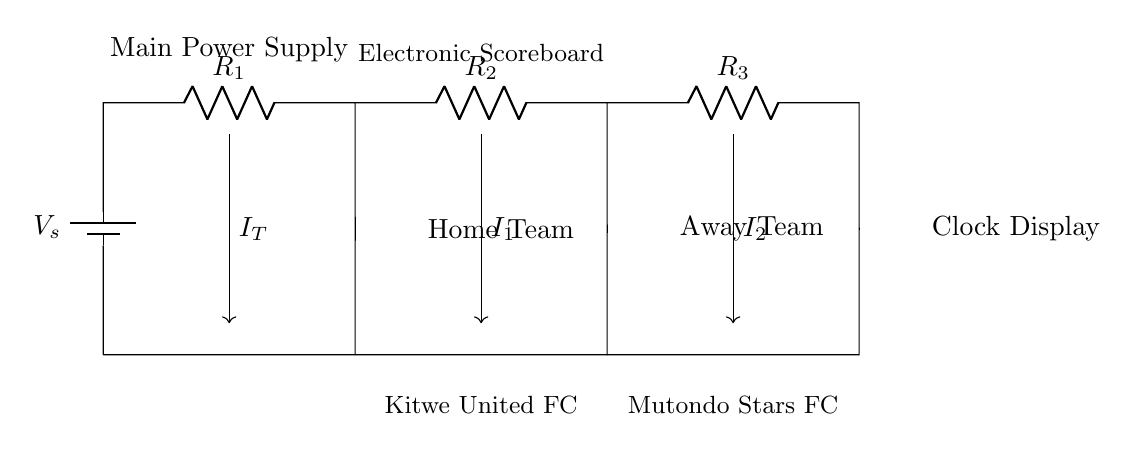What is the total current supplied by the battery? The total current supplied by the battery is denoted as I_T, which is the sum of all currents flowing to the individual branches that power the scoreboard.
Answer: I_T How many resistors are in the circuit? The circuit features three resistors, labeled as R1, R2, and R3, connected in parallel to the main voltage source.
Answer: Three What is the function of the power supply in this circuit? The power supply, represented by the battery, provides the necessary voltage to power the electronic scoreboard and distribute current to the connected components.
Answer: Voltage supply Which team has a separate current flowing to its display? The away team, represented by the current labeled I2, has a separate current flowing to its display, distinct from the home team.
Answer: Away Team What type of current divider is depicted in this circuit? The circuit shows a parallel current divider, where the total current splits into separate paths, each with its current flowing through individual resistors.
Answer: Parallel current divider How is the current split among the resistors? The current is split according to the resistance values; based on Ohm's law, the current through each resistor (I1, I2) can be calculated using the respective resistances and total current supplied.
Answer: Proportional to resistance 